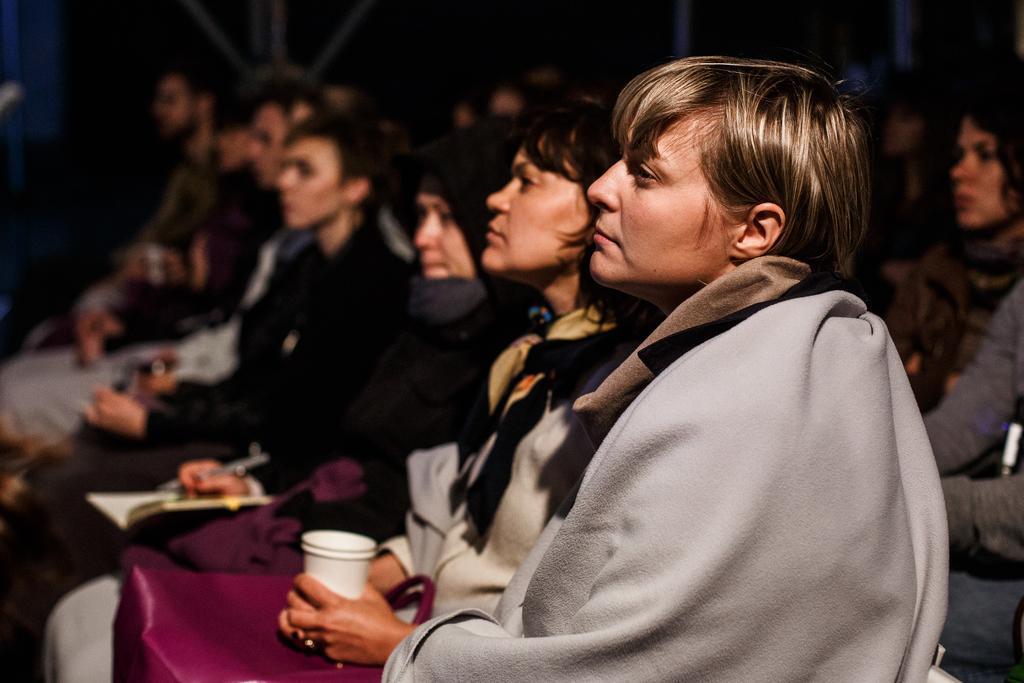In one or two sentences, can you explain what this image depicts? In front of the image there are people sitting on the chairs. Behind them there are metal rods. 